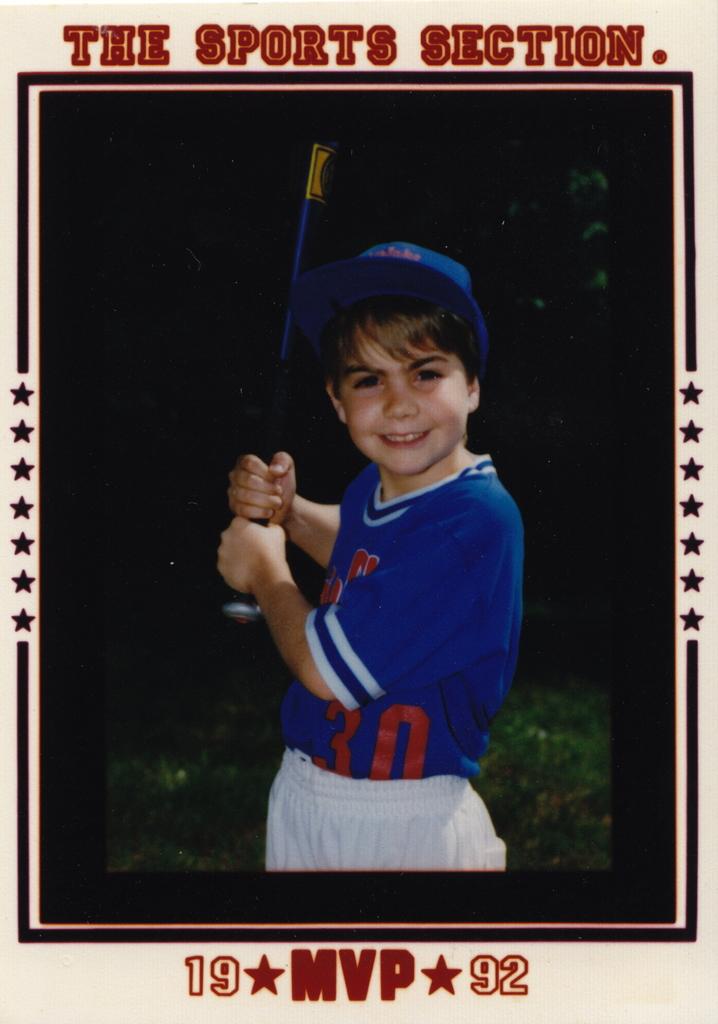What section will this be in?
Provide a succinct answer. Sports. 